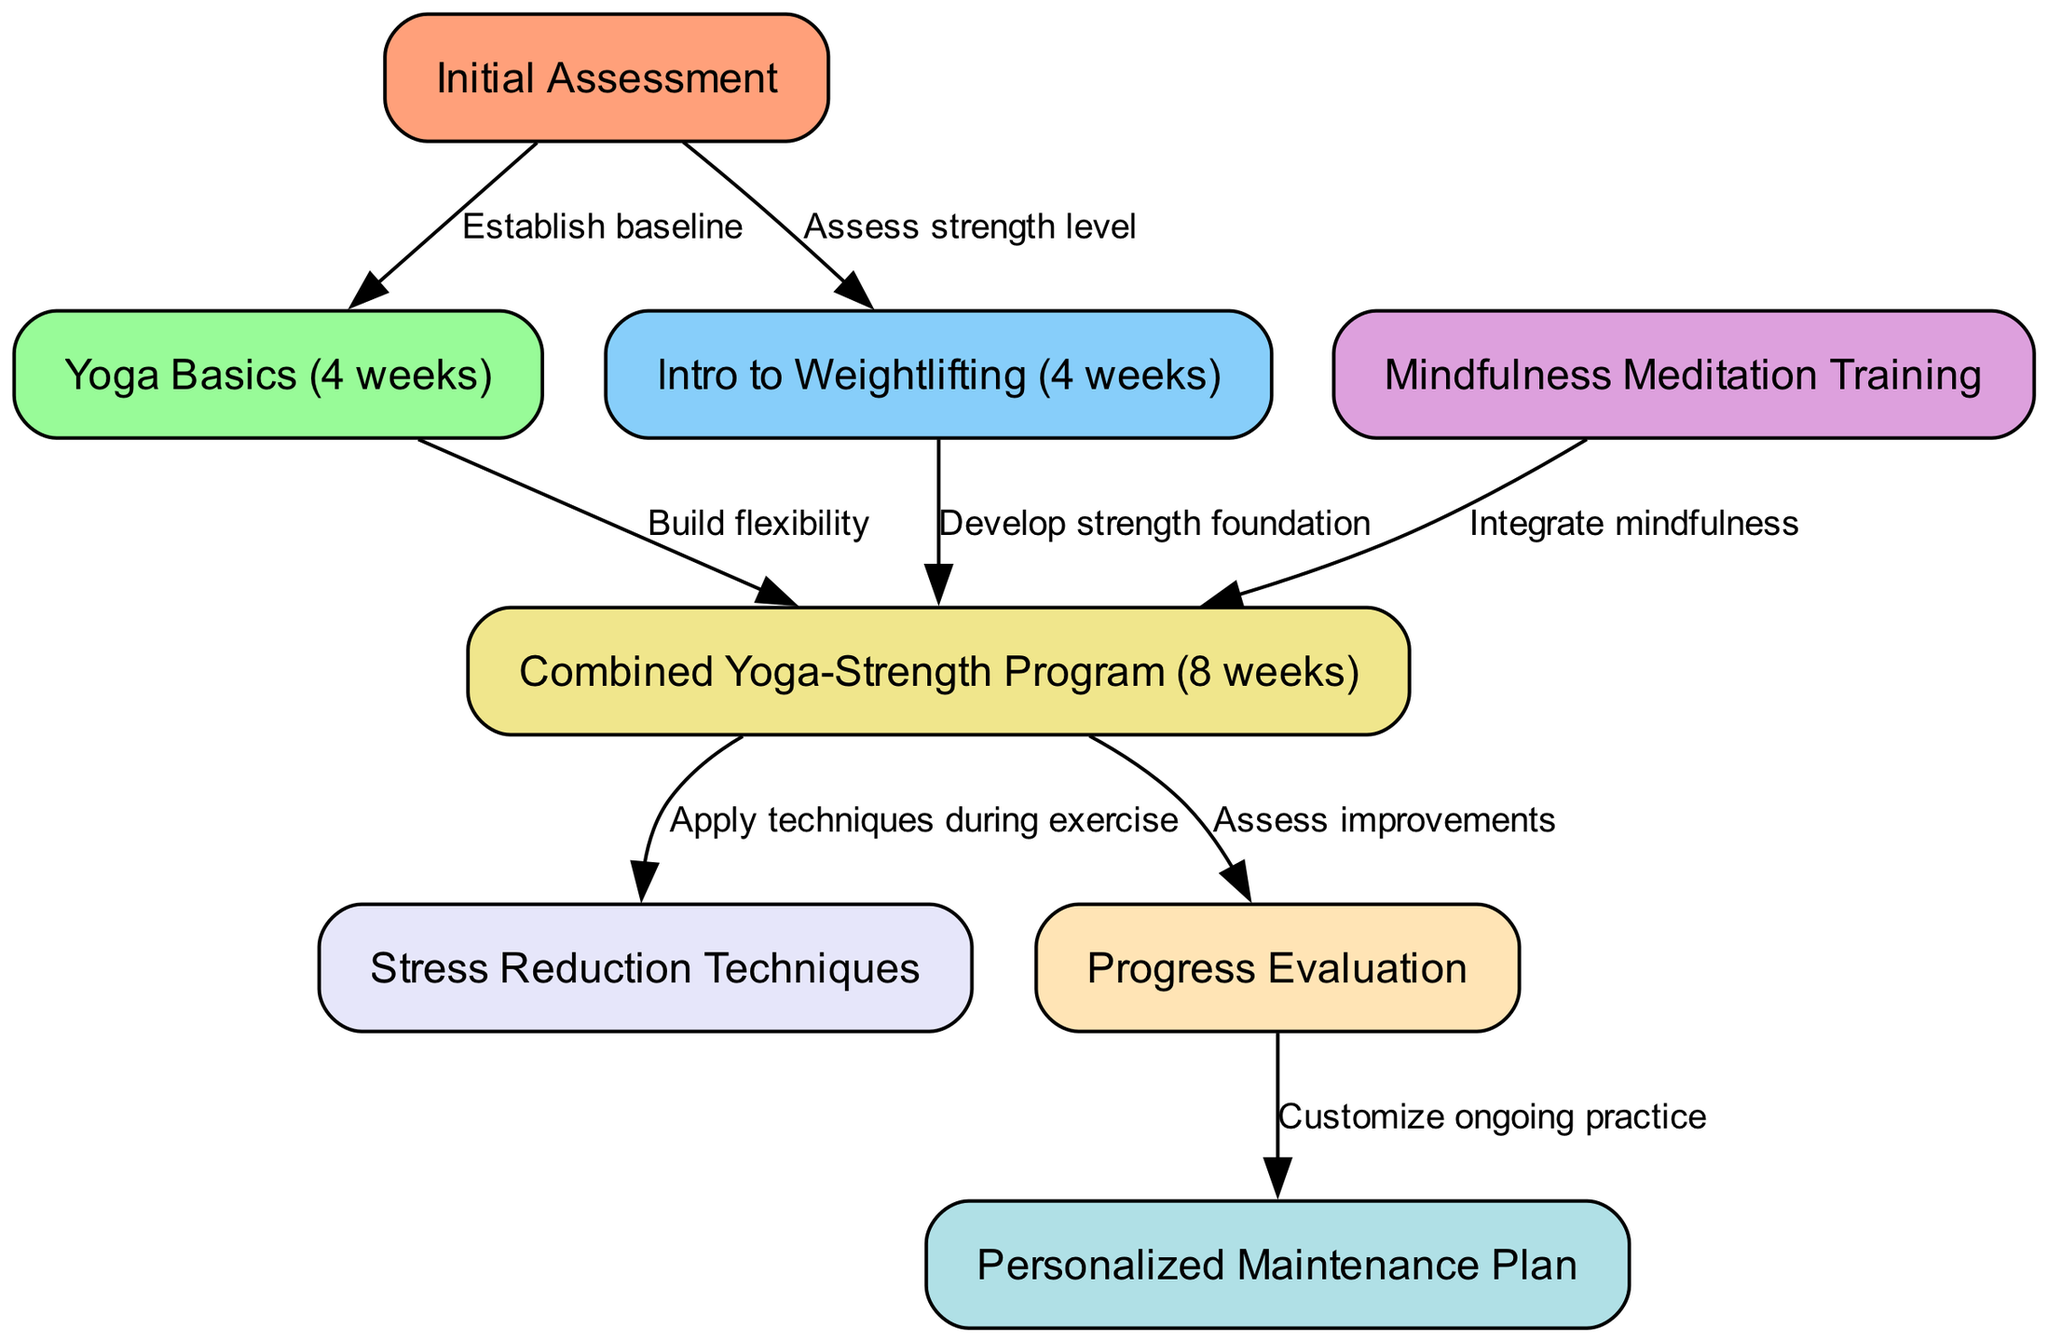What's the total number of nodes in the diagram? The diagram lists eight identifiable components that represent different stages or actions within the clinical pathway. These nodes include Initial Assessment, Yoga Basics, Intro to Weightlifting, Mindfulness Meditation Training, Combined Yoga-Strength Program, Stress Reduction Techniques, Progress Evaluation, and Personalized Maintenance Plan. Counting these, we get a total of 8 nodes.
Answer: 8 What is the first step in the pathway? The first node in the diagram is labeled "Initial Assessment," which represents the starting point for participants entering the program. There are no nodes before this one.
Answer: Initial Assessment What connects the "Initial Assessment" to "Yoga Basics"? The arrow between "Initial Assessment" and "Yoga Basics" indicates a relationship wherein the initial assessment establishes baseline metrics, leading to the implementation of yoga basics. The text provided on the edge denotes the purpose of this connection, which is to establish a baseline.
Answer: Establish baseline How many weeks does the Combined Yoga-Strength Program last? The node titled "Combined Yoga-Strength Program" is explicitly noted to last for 8 weeks, providing a clear timeline for that part of the pathway within the overall program structure.
Answer: 8 weeks What is the last node in the pathway? The diagram indicates that the final step after the "Progress Evaluation" is the "Personalized Maintenance Plan." This shows that the pathway concludes with customizing ongoing practices for participants.
Answer: Personalized Maintenance Plan Which node integrates mindfulness into the program? The connection between "Mindfulness Meditation Training" and "Combined Yoga-Strength Program" clearly states that mindfulness training is integrated into this combined program, thereby enhancing its effectiveness. The edge text illustrates the purpose of this step, highlighting the integration of mindfulness.
Answer: Integrate mindfulness What relationship exists between "Combined Yoga-Strength Program" and "Stress Reduction Techniques"? The arrow suggests that "Stress Reduction Techniques" are applied during the "Combined Yoga-Strength Program," which implies that these techniques are not just taught but practically implemented within the context of the exercise program. This is indicated by the text on the edge.
Answer: Apply techniques during exercise How many edges are in the diagram? The diagram lists seven directed relationships connecting various nodes. Each of these relationships is represented by an arrow indicating the flow from one stage to another, allowing us to count a total of 7 edges.
Answer: 7 What is assessed after the "Combined Yoga-Strength Program"? Following the "Combined Yoga-Strength Program," the next logical step noted in the pathway is "Progress Evaluation," suggesting that the effectiveness and improvements from the program will be measured at this stage.
Answer: Progress Evaluation 